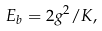Convert formula to latex. <formula><loc_0><loc_0><loc_500><loc_500>E _ { b } = 2 g ^ { 2 } / K ,</formula> 